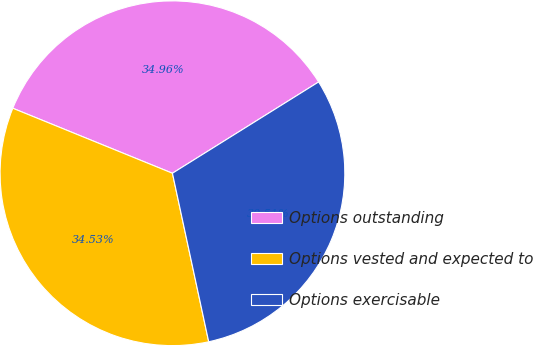Convert chart to OTSL. <chart><loc_0><loc_0><loc_500><loc_500><pie_chart><fcel>Options outstanding<fcel>Options vested and expected to<fcel>Options exercisable<nl><fcel>34.96%<fcel>34.53%<fcel>30.51%<nl></chart> 